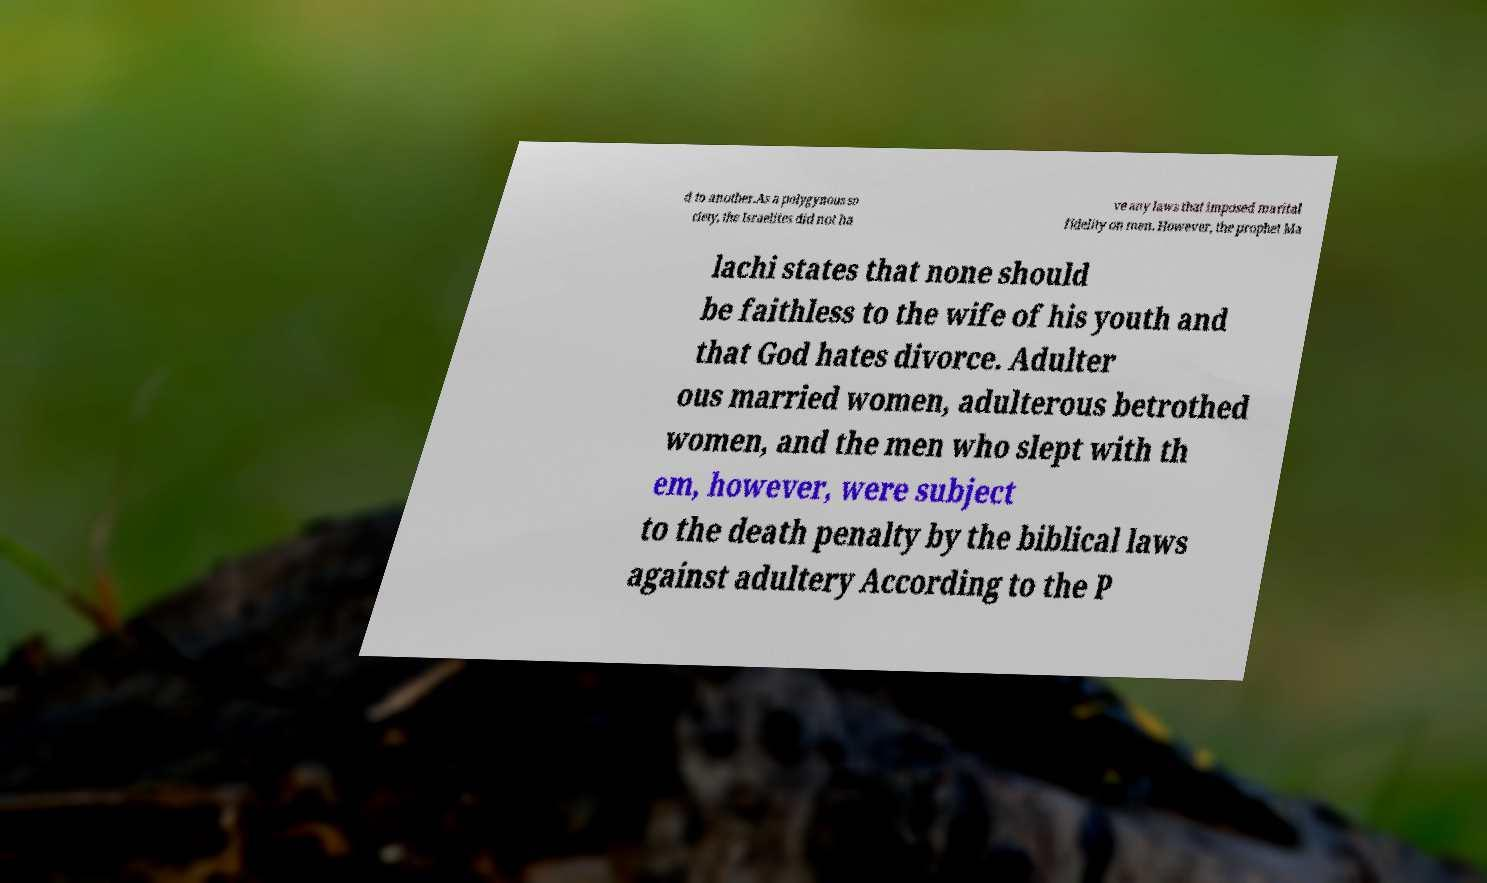Please identify and transcribe the text found in this image. d to another.As a polygynous so ciety, the Israelites did not ha ve any laws that imposed marital fidelity on men. However, the prophet Ma lachi states that none should be faithless to the wife of his youth and that God hates divorce. Adulter ous married women, adulterous betrothed women, and the men who slept with th em, however, were subject to the death penalty by the biblical laws against adultery According to the P 